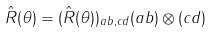<formula> <loc_0><loc_0><loc_500><loc_500>\hat { R } ( \theta ) = ( { \hat { R } } ( \theta ) ) _ { a b , c d } ( a b ) \otimes ( c d )</formula> 